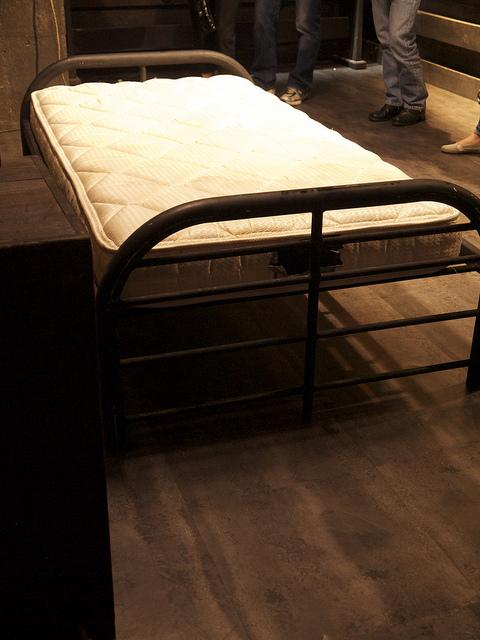What usually happens on the item in the middle of the room?

Choices:
A) cooking
B) hitting homeruns
C) shooting hoops
D) sleeping sleeping 